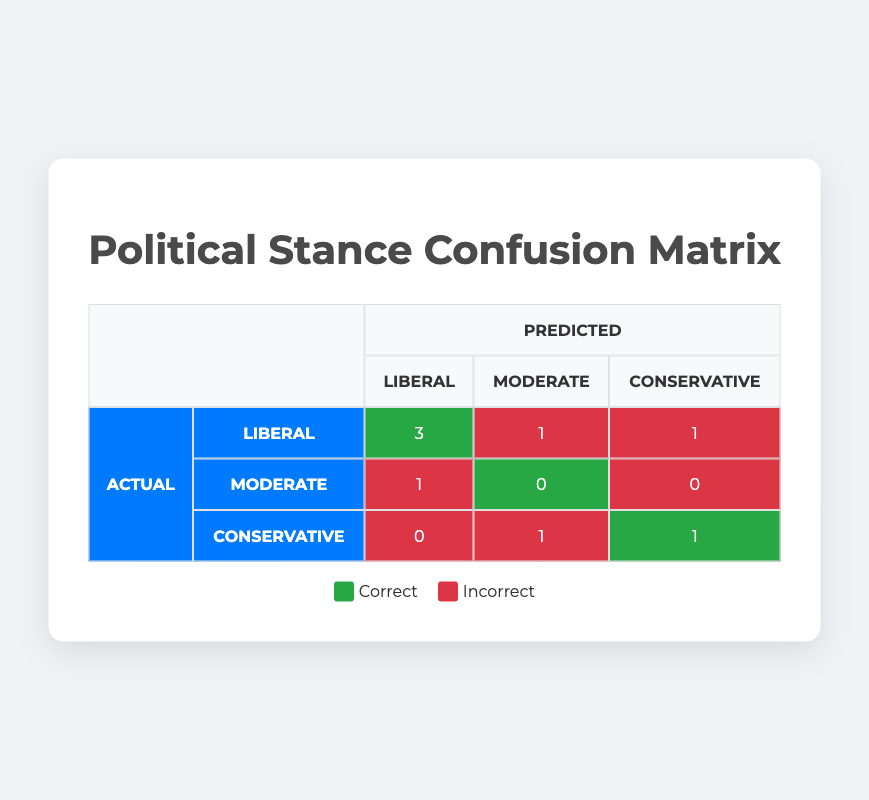What is the total number of users whose political stance was predicted as Liberal? To find this, we count the entries in the "Predicted" column that indicate "Liberal". In the table, there are three users predicted to be Liberal (user IDs 1, 4, and 7), so the total is 3.
Answer: 3 How many users had their political stance incorrectly predicted? To answer this, we can look at the "incorrect" counts in the matrix. There are 1 user mispredicted as Liberal (actual Moderate), 1 mispredicted as Moderate (actual Liberal), 1 mispredicted as Conservative (actual Liberal), and 1 mispredicted as Moderate (actual Conservative). Thus, 1 + 1 + 1 + 1 = 4 users had incorrect predictions.
Answer: 4 What is the total number of users whose actual political stance is Conservative? By examining the "Actual" column, we can see there is 1 user whose actual stance is Conservative (user ID 6). Therefore, the total is 1.
Answer: 1 Is it true that the predicted stance of all users from New York who were analyzed is Liberal? Checking the data, user ID 4 from New York is predicted as Liberal, but since user ID 5, who is from a different location, was incorrectly predicted, we need to clarify that only user ID 4's stance is Liberal. Since there's no other user from New York listed, the statement is true.
Answer: Yes How many users were correctly predicted as Liberal and had a Masters or Doctorate education? From the table, we need to identify users with a predicted stance of Liberal and check their education level. User ID 4 (Doctorate) and user ID 7 (Masters) are both correctly predicted as Liberal. Counting them, we find there are 2 users with the specified criteria.
Answer: 2 What is the difference in the number of correctly predicted Liberal users and Moderately predicted users? The table shows 3 correctly predicted Liberal users and 0 correctly predicted Moderate users. The difference is calculated as 3 (correct for Liberal) - 0 (correct for Moderate) = 3.
Answer: 3 Which user has the highest age among those whose political stance was incorrectly predicted as Liberal? We need to check entries with the predicted stance of Liberal but were incorrect. The only user here is user ID 5 who is actually Moderate and aged 53. This user has the highest age among those inaccurately predicted as Liberal.
Answer: 53 How many total predictions were made for Liberal stances and how many of them were correct? To find this, look for predictions made for Liberal stances. In total, there are 4 predictions for Liberal. Among these, 3 were correct (ID 1, 4, and 7), and 1 was incorrect (ID 5). 
Thus, correct predictions = 3.
Answer: 4, 3 